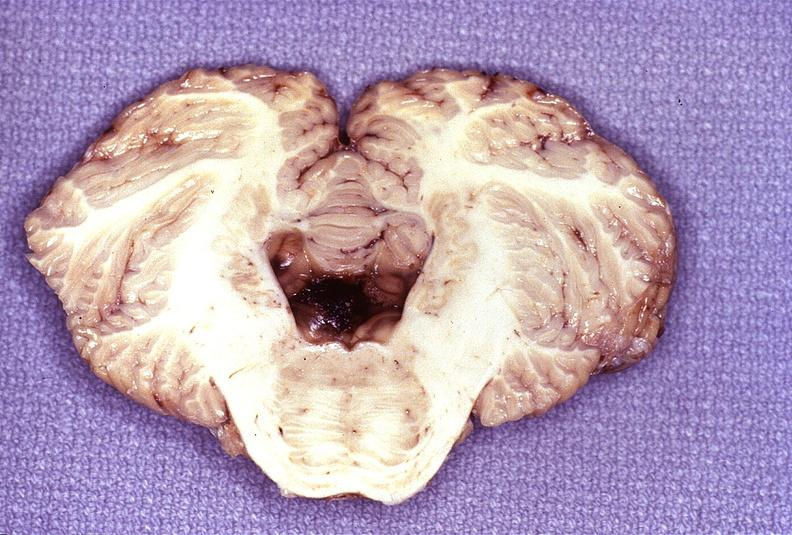what is present?
Answer the question using a single word or phrase. Nervous 